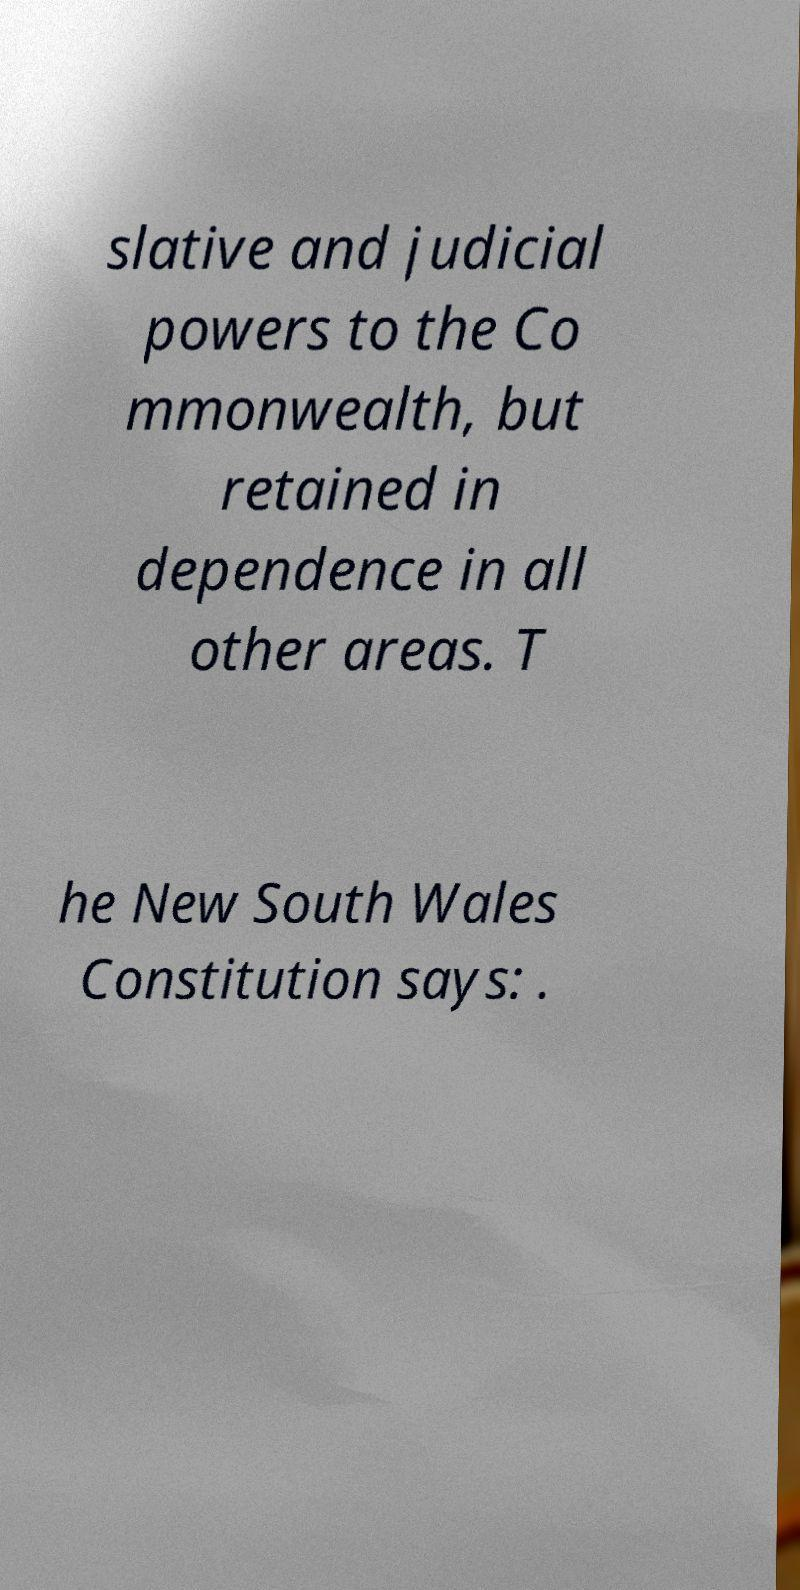I need the written content from this picture converted into text. Can you do that? slative and judicial powers to the Co mmonwealth, but retained in dependence in all other areas. T he New South Wales Constitution says: . 